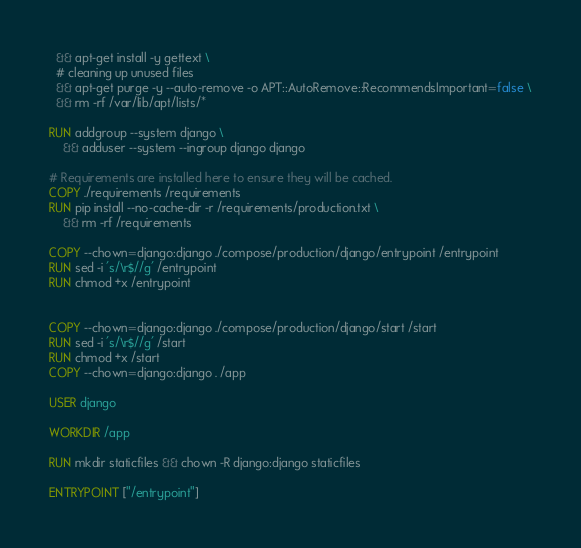Convert code to text. <code><loc_0><loc_0><loc_500><loc_500><_Dockerfile_>  && apt-get install -y gettext \
  # cleaning up unused files
  && apt-get purge -y --auto-remove -o APT::AutoRemove::RecommendsImportant=false \
  && rm -rf /var/lib/apt/lists/*

RUN addgroup --system django \
    && adduser --system --ingroup django django

# Requirements are installed here to ensure they will be cached.
COPY ./requirements /requirements
RUN pip install --no-cache-dir -r /requirements/production.txt \
    && rm -rf /requirements

COPY --chown=django:django ./compose/production/django/entrypoint /entrypoint
RUN sed -i 's/\r$//g' /entrypoint
RUN chmod +x /entrypoint


COPY --chown=django:django ./compose/production/django/start /start
RUN sed -i 's/\r$//g' /start
RUN chmod +x /start
COPY --chown=django:django . /app

USER django

WORKDIR /app

RUN mkdir staticfiles && chown -R django:django staticfiles

ENTRYPOINT ["/entrypoint"]
</code> 